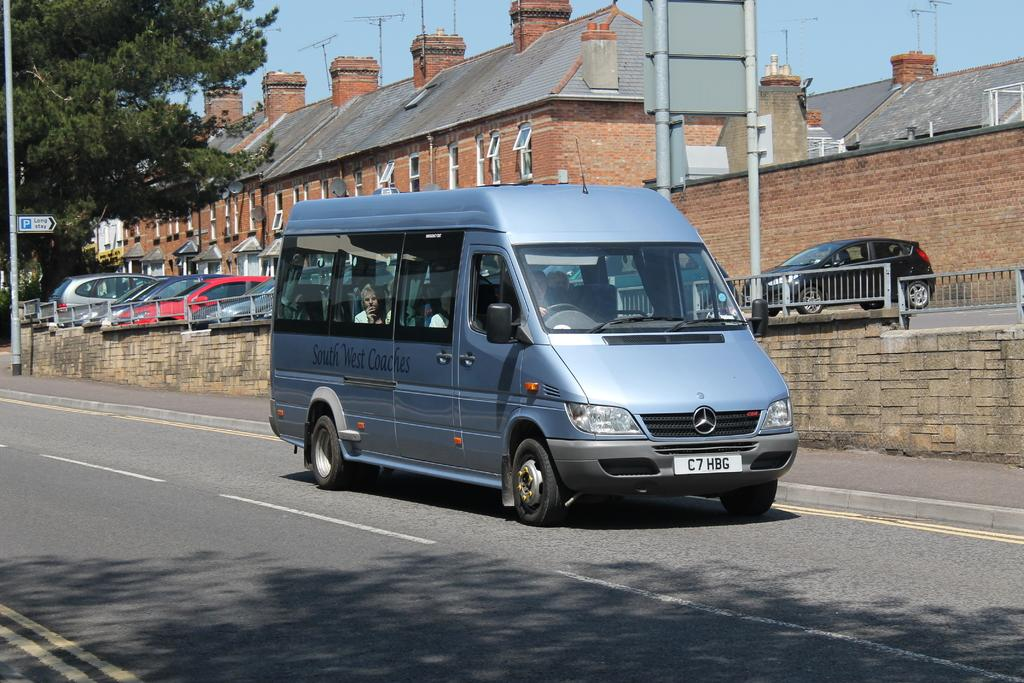Provide a one-sentence caption for the provided image. A large blue Mercedes van with the license plate C7HBG. 